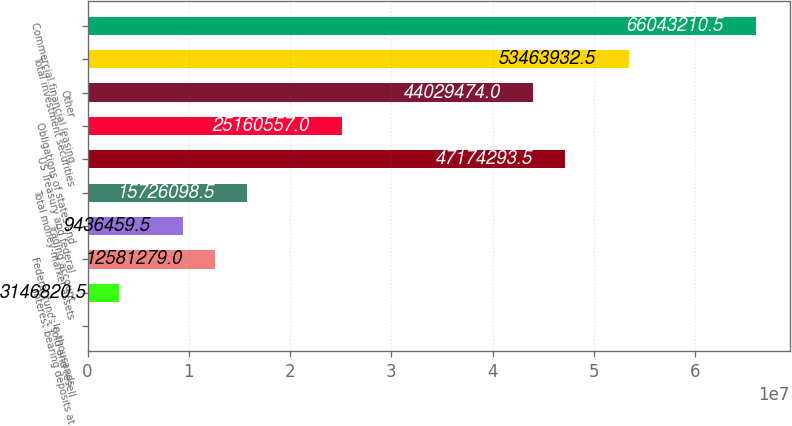Convert chart. <chart><loc_0><loc_0><loc_500><loc_500><bar_chart><fcel>In thousands<fcel>Interest-bearing deposits at<fcel>Federal funds sold and resell<fcel>Trading account<fcel>Total money-market assets<fcel>US Treasury and federal<fcel>Obligations of states and<fcel>Other<fcel>Total investment securities<fcel>Commercial financial leasing<nl><fcel>2001<fcel>3.14682e+06<fcel>1.25813e+07<fcel>9.43646e+06<fcel>1.57261e+07<fcel>4.71743e+07<fcel>2.51606e+07<fcel>4.40295e+07<fcel>5.34639e+07<fcel>6.60432e+07<nl></chart> 